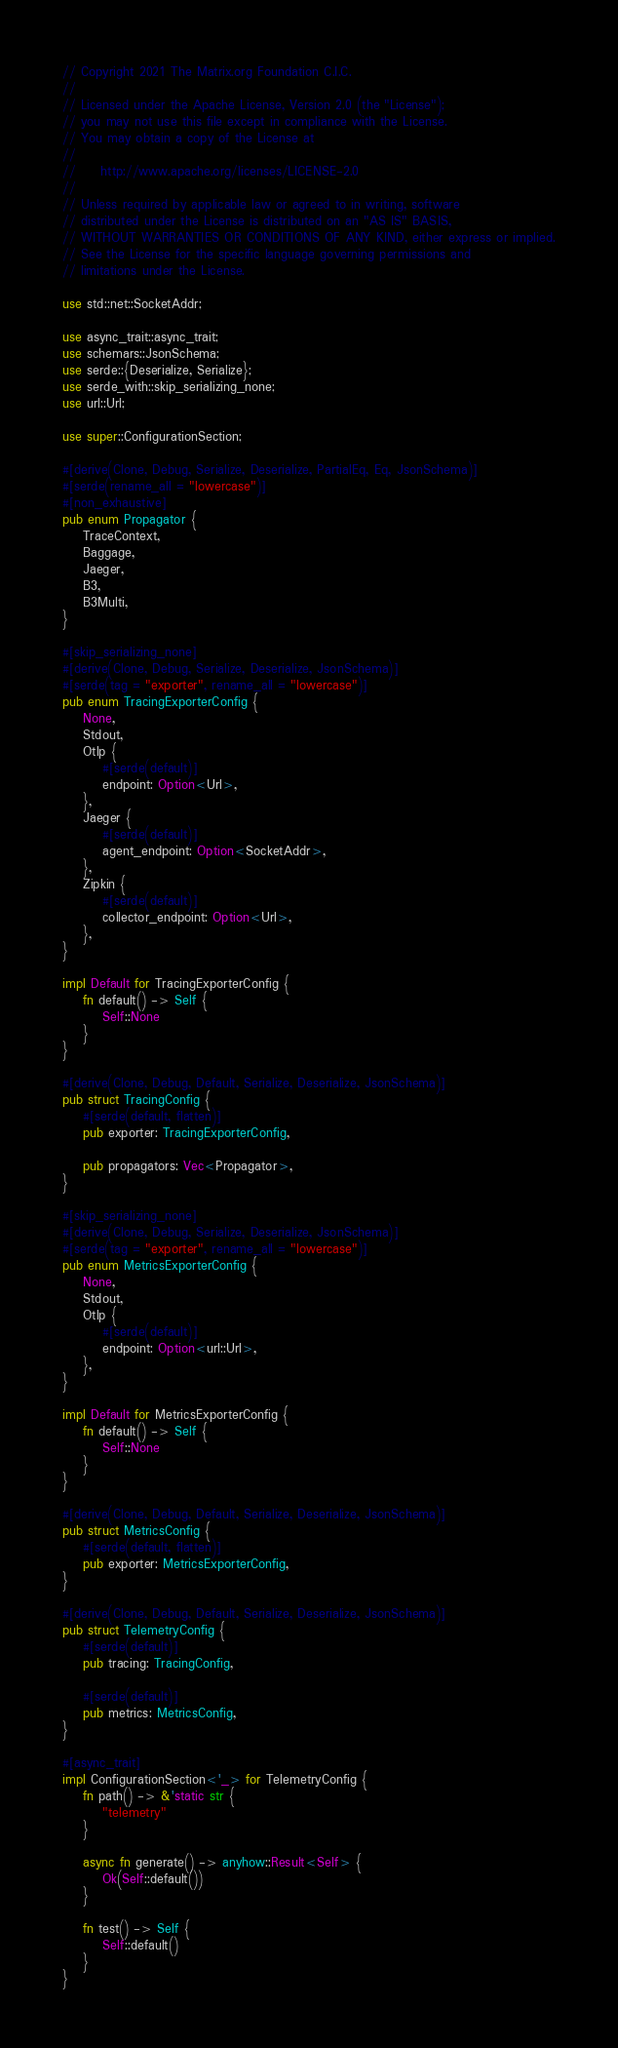Convert code to text. <code><loc_0><loc_0><loc_500><loc_500><_Rust_>// Copyright 2021 The Matrix.org Foundation C.I.C.
//
// Licensed under the Apache License, Version 2.0 (the "License");
// you may not use this file except in compliance with the License.
// You may obtain a copy of the License at
//
//     http://www.apache.org/licenses/LICENSE-2.0
//
// Unless required by applicable law or agreed to in writing, software
// distributed under the License is distributed on an "AS IS" BASIS,
// WITHOUT WARRANTIES OR CONDITIONS OF ANY KIND, either express or implied.
// See the License for the specific language governing permissions and
// limitations under the License.

use std::net::SocketAddr;

use async_trait::async_trait;
use schemars::JsonSchema;
use serde::{Deserialize, Serialize};
use serde_with::skip_serializing_none;
use url::Url;

use super::ConfigurationSection;

#[derive(Clone, Debug, Serialize, Deserialize, PartialEq, Eq, JsonSchema)]
#[serde(rename_all = "lowercase")]
#[non_exhaustive]
pub enum Propagator {
    TraceContext,
    Baggage,
    Jaeger,
    B3,
    B3Multi,
}

#[skip_serializing_none]
#[derive(Clone, Debug, Serialize, Deserialize, JsonSchema)]
#[serde(tag = "exporter", rename_all = "lowercase")]
pub enum TracingExporterConfig {
    None,
    Stdout,
    Otlp {
        #[serde(default)]
        endpoint: Option<Url>,
    },
    Jaeger {
        #[serde(default)]
        agent_endpoint: Option<SocketAddr>,
    },
    Zipkin {
        #[serde(default)]
        collector_endpoint: Option<Url>,
    },
}

impl Default for TracingExporterConfig {
    fn default() -> Self {
        Self::None
    }
}

#[derive(Clone, Debug, Default, Serialize, Deserialize, JsonSchema)]
pub struct TracingConfig {
    #[serde(default, flatten)]
    pub exporter: TracingExporterConfig,

    pub propagators: Vec<Propagator>,
}

#[skip_serializing_none]
#[derive(Clone, Debug, Serialize, Deserialize, JsonSchema)]
#[serde(tag = "exporter", rename_all = "lowercase")]
pub enum MetricsExporterConfig {
    None,
    Stdout,
    Otlp {
        #[serde(default)]
        endpoint: Option<url::Url>,
    },
}

impl Default for MetricsExporterConfig {
    fn default() -> Self {
        Self::None
    }
}

#[derive(Clone, Debug, Default, Serialize, Deserialize, JsonSchema)]
pub struct MetricsConfig {
    #[serde(default, flatten)]
    pub exporter: MetricsExporterConfig,
}

#[derive(Clone, Debug, Default, Serialize, Deserialize, JsonSchema)]
pub struct TelemetryConfig {
    #[serde(default)]
    pub tracing: TracingConfig,

    #[serde(default)]
    pub metrics: MetricsConfig,
}

#[async_trait]
impl ConfigurationSection<'_> for TelemetryConfig {
    fn path() -> &'static str {
        "telemetry"
    }

    async fn generate() -> anyhow::Result<Self> {
        Ok(Self::default())
    }

    fn test() -> Self {
        Self::default()
    }
}
</code> 